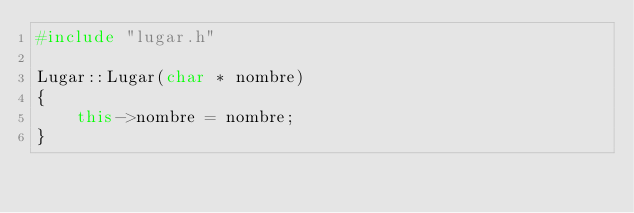Convert code to text. <code><loc_0><loc_0><loc_500><loc_500><_C++_>#include "lugar.h"

Lugar::Lugar(char * nombre)
{
    this->nombre = nombre;
}
</code> 